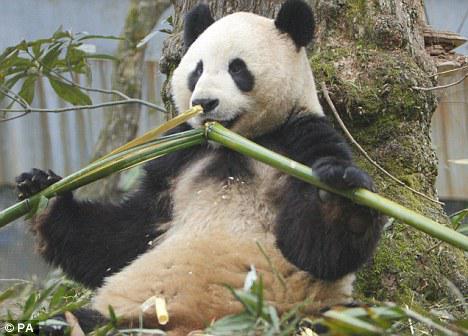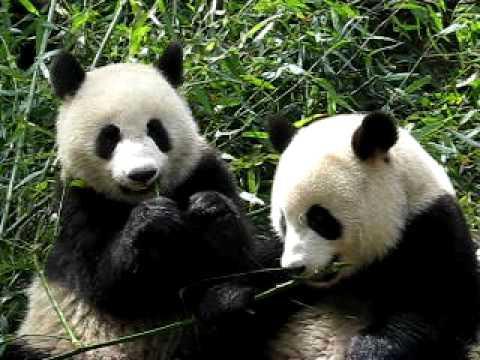The first image is the image on the left, the second image is the image on the right. For the images shown, is this caption "There are three pandas" true? Answer yes or no. Yes. 